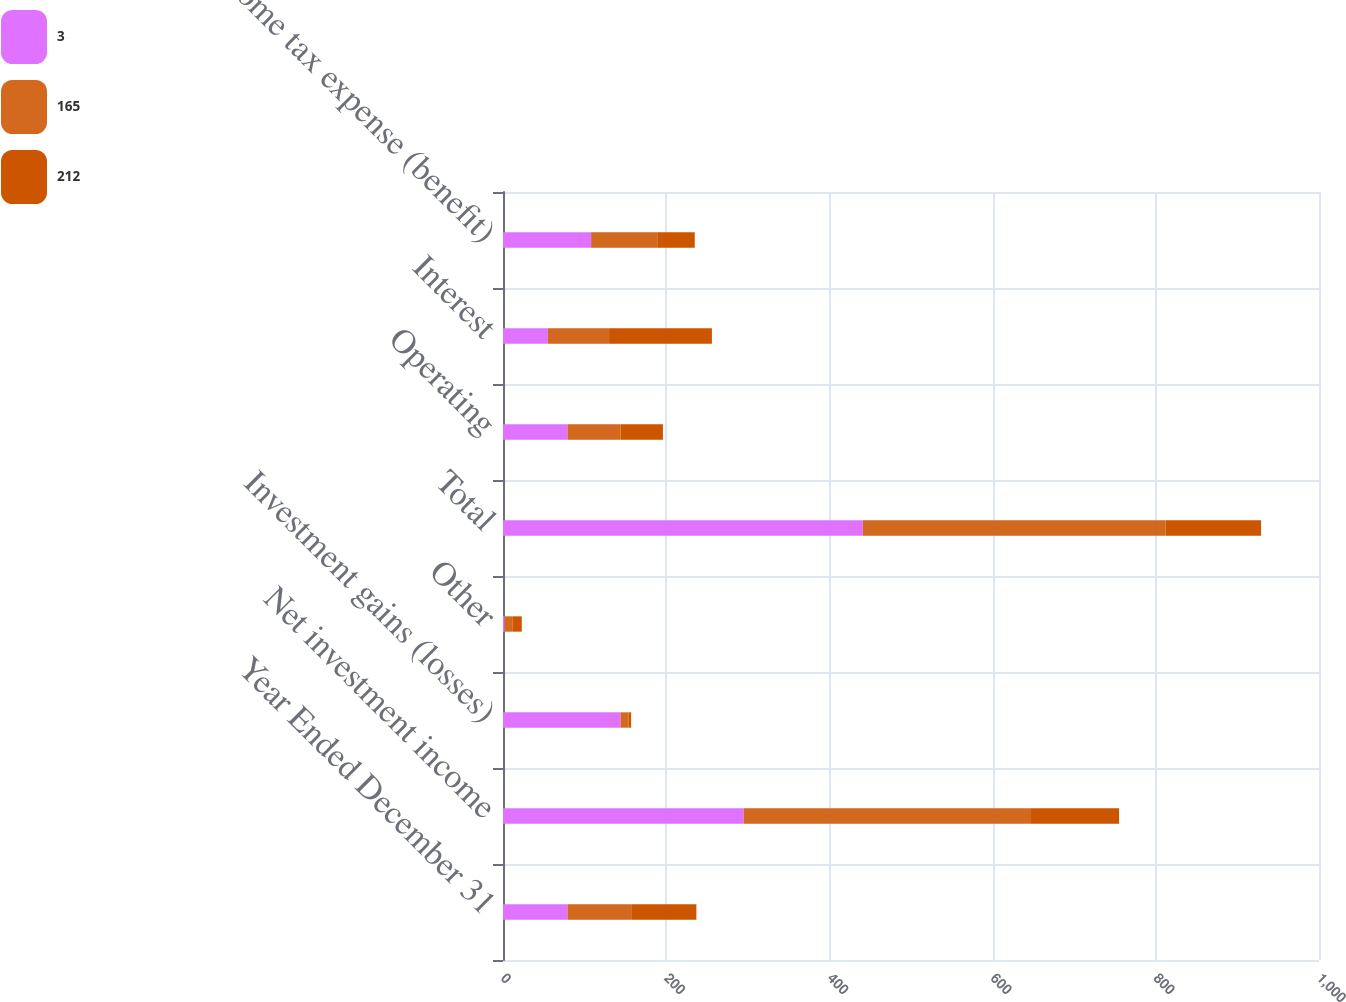Convert chart. <chart><loc_0><loc_0><loc_500><loc_500><stacked_bar_chart><ecel><fcel>Year Ended December 31<fcel>Net investment income<fcel>Investment gains (losses)<fcel>Other<fcel>Total<fcel>Operating<fcel>Interest<fcel>Income tax expense (benefit)<nl><fcel>3<fcel>79<fcel>295<fcel>144<fcel>2<fcel>441<fcel>79<fcel>55<fcel>108<nl><fcel>165<fcel>79<fcel>351<fcel>10<fcel>10<fcel>371<fcel>65<fcel>75<fcel>81<nl><fcel>212<fcel>79<fcel>109<fcel>3<fcel>11<fcel>117<fcel>52<fcel>126<fcel>46<nl></chart> 